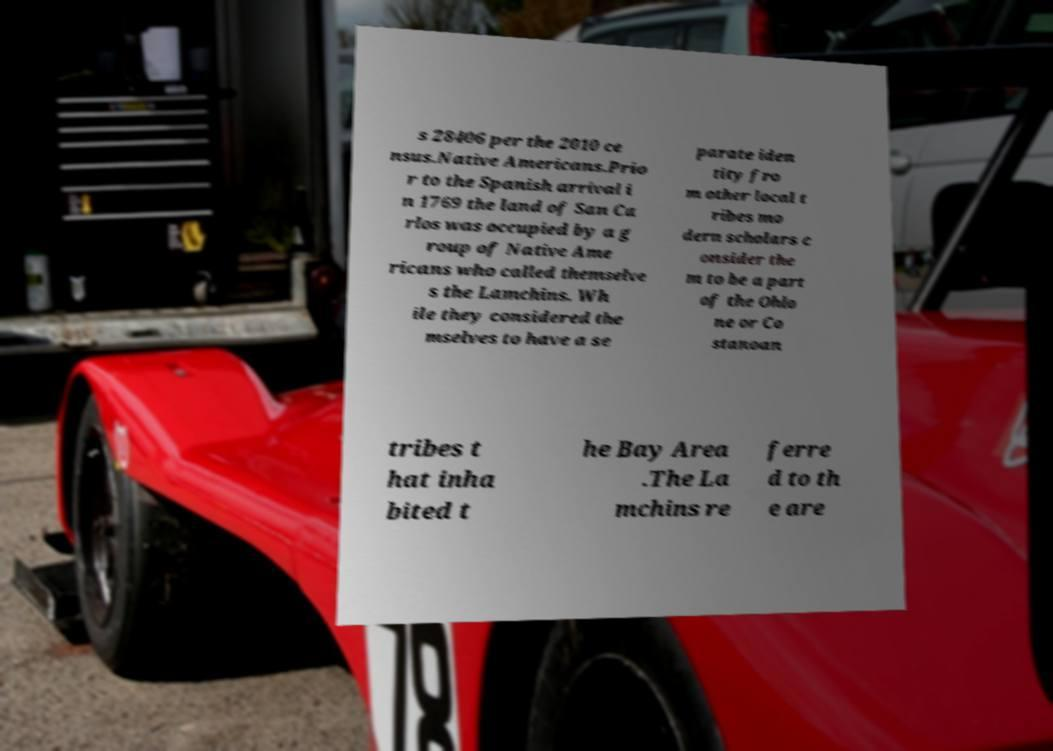What messages or text are displayed in this image? I need them in a readable, typed format. s 28406 per the 2010 ce nsus.Native Americans.Prio r to the Spanish arrival i n 1769 the land of San Ca rlos was occupied by a g roup of Native Ame ricans who called themselve s the Lamchins. Wh ile they considered the mselves to have a se parate iden tity fro m other local t ribes mo dern scholars c onsider the m to be a part of the Ohlo ne or Co stanoan tribes t hat inha bited t he Bay Area .The La mchins re ferre d to th e are 